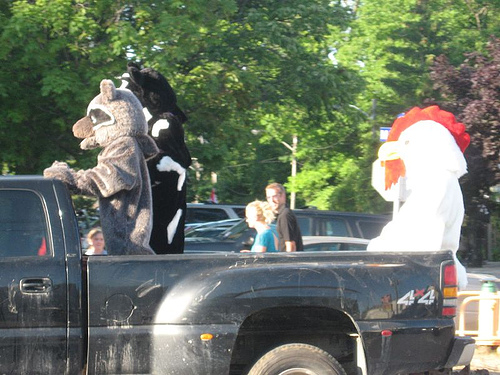<image>
Can you confirm if the man is behind the truck? No. The man is not behind the truck. From this viewpoint, the man appears to be positioned elsewhere in the scene. 